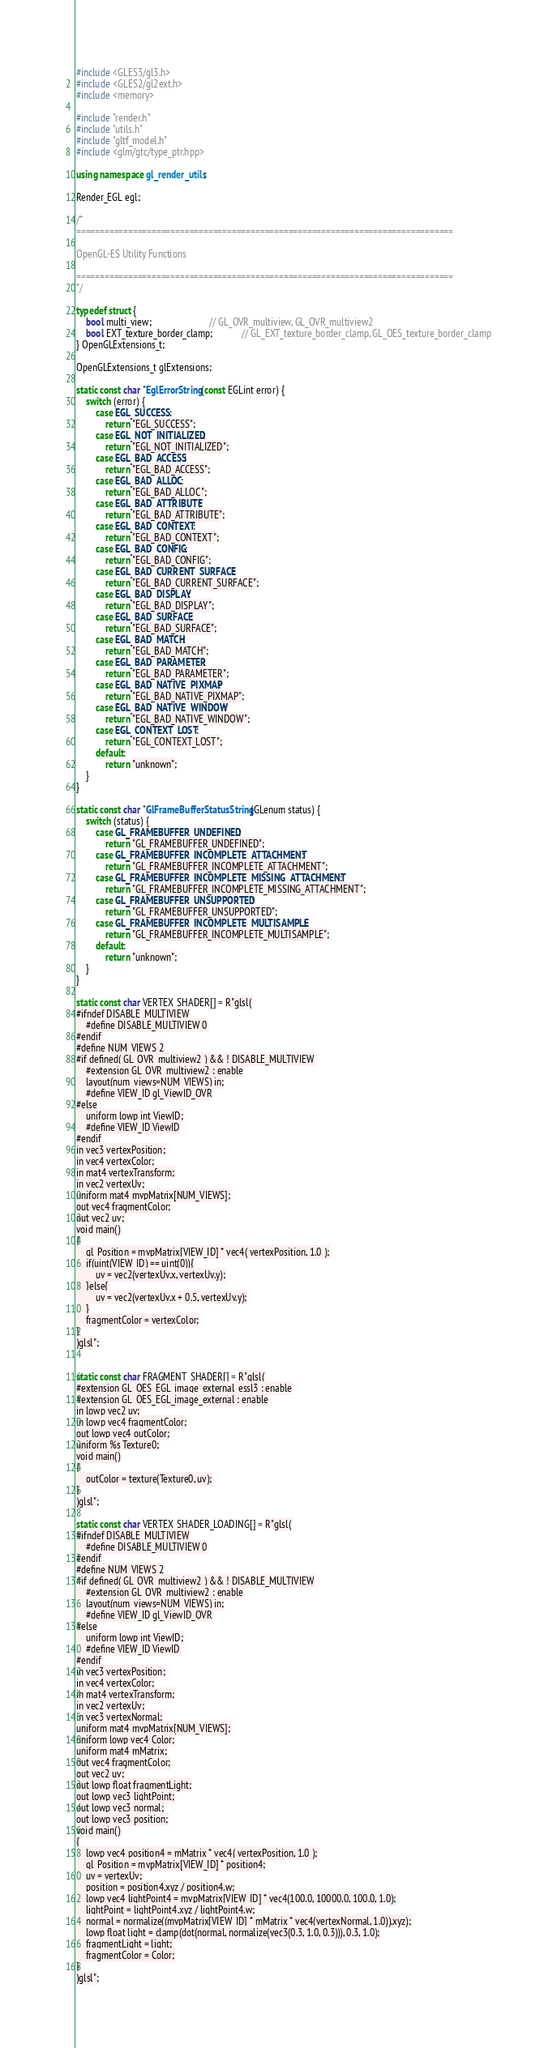<code> <loc_0><loc_0><loc_500><loc_500><_C++_>#include <GLES3/gl3.h>
#include <GLES2/gl2ext.h>
#include <memory>

#include "render.h"
#include "utils.h"
#include "gltf_model.h"
#include <glm/gtc/type_ptr.hpp>

using namespace gl_render_utils;

Render_EGL egl;

/*
================================================================================

OpenGL-ES Utility Functions

================================================================================
*/

typedef struct {
    bool multi_view;                        // GL_OVR_multiview, GL_OVR_multiview2
    bool EXT_texture_border_clamp;            // GL_EXT_texture_border_clamp, GL_OES_texture_border_clamp
} OpenGLExtensions_t;

OpenGLExtensions_t glExtensions;

static const char *EglErrorString(const EGLint error) {
    switch (error) {
        case EGL_SUCCESS:
            return "EGL_SUCCESS";
        case EGL_NOT_INITIALIZED:
            return "EGL_NOT_INITIALIZED";
        case EGL_BAD_ACCESS:
            return "EGL_BAD_ACCESS";
        case EGL_BAD_ALLOC:
            return "EGL_BAD_ALLOC";
        case EGL_BAD_ATTRIBUTE:
            return "EGL_BAD_ATTRIBUTE";
        case EGL_BAD_CONTEXT:
            return "EGL_BAD_CONTEXT";
        case EGL_BAD_CONFIG:
            return "EGL_BAD_CONFIG";
        case EGL_BAD_CURRENT_SURFACE:
            return "EGL_BAD_CURRENT_SURFACE";
        case EGL_BAD_DISPLAY:
            return "EGL_BAD_DISPLAY";
        case EGL_BAD_SURFACE:
            return "EGL_BAD_SURFACE";
        case EGL_BAD_MATCH:
            return "EGL_BAD_MATCH";
        case EGL_BAD_PARAMETER:
            return "EGL_BAD_PARAMETER";
        case EGL_BAD_NATIVE_PIXMAP:
            return "EGL_BAD_NATIVE_PIXMAP";
        case EGL_BAD_NATIVE_WINDOW:
            return "EGL_BAD_NATIVE_WINDOW";
        case EGL_CONTEXT_LOST:
            return "EGL_CONTEXT_LOST";
        default:
            return "unknown";
    }
}

static const char *GlFrameBufferStatusString(GLenum status) {
    switch (status) {
        case GL_FRAMEBUFFER_UNDEFINED:
            return "GL_FRAMEBUFFER_UNDEFINED";
        case GL_FRAMEBUFFER_INCOMPLETE_ATTACHMENT:
            return "GL_FRAMEBUFFER_INCOMPLETE_ATTACHMENT";
        case GL_FRAMEBUFFER_INCOMPLETE_MISSING_ATTACHMENT:
            return "GL_FRAMEBUFFER_INCOMPLETE_MISSING_ATTACHMENT";
        case GL_FRAMEBUFFER_UNSUPPORTED:
            return "GL_FRAMEBUFFER_UNSUPPORTED";
        case GL_FRAMEBUFFER_INCOMPLETE_MULTISAMPLE:
            return "GL_FRAMEBUFFER_INCOMPLETE_MULTISAMPLE";
        default:
            return "unknown";
    }
}

static const char VERTEX_SHADER[] = R"glsl(
#ifndef DISABLE_MULTIVIEW
    #define DISABLE_MULTIVIEW 0
#endif
#define NUM_VIEWS 2
#if defined( GL_OVR_multiview2 ) && ! DISABLE_MULTIVIEW
    #extension GL_OVR_multiview2 : enable
    layout(num_views=NUM_VIEWS) in;
    #define VIEW_ID gl_ViewID_OVR
#else
    uniform lowp int ViewID;
    #define VIEW_ID ViewID
#endif
in vec3 vertexPosition;
in vec4 vertexColor;
in mat4 vertexTransform;
in vec2 vertexUv;
uniform mat4 mvpMatrix[NUM_VIEWS];
out vec4 fragmentColor;
out vec2 uv;
void main()
{
    gl_Position = mvpMatrix[VIEW_ID] * vec4( vertexPosition, 1.0 );
    if(uint(VIEW_ID) == uint(0)){
        uv = vec2(vertexUv.x, vertexUv.y);
    }else{
        uv = vec2(vertexUv.x + 0.5, vertexUv.y);
    }
    fragmentColor = vertexColor;
}
)glsl";


static const char FRAGMENT_SHADER[] = R"glsl(
#extension GL_OES_EGL_image_external_essl3 : enable
#extension GL_OES_EGL_image_external : enable
in lowp vec2 uv;
in lowp vec4 fragmentColor;
out lowp vec4 outColor;
uniform %s Texture0;
void main()
{
    outColor = texture(Texture0, uv);
}
)glsl";

static const char VERTEX_SHADER_LOADING[] = R"glsl(
#ifndef DISABLE_MULTIVIEW
    #define DISABLE_MULTIVIEW 0
#endif
#define NUM_VIEWS 2
#if defined( GL_OVR_multiview2 ) && ! DISABLE_MULTIVIEW
    #extension GL_OVR_multiview2 : enable
    layout(num_views=NUM_VIEWS) in;
    #define VIEW_ID gl_ViewID_OVR
#else
    uniform lowp int ViewID;
    #define VIEW_ID ViewID
#endif
in vec3 vertexPosition;
in vec4 vertexColor;
in mat4 vertexTransform;
in vec2 vertexUv;
in vec3 vertexNormal;
uniform mat4 mvpMatrix[NUM_VIEWS];
uniform lowp vec4 Color;
uniform mat4 mMatrix;
out vec4 fragmentColor;
out vec2 uv;
out lowp float fragmentLight;
out lowp vec3 lightPoint;
out lowp vec3 normal;
out lowp vec3 position;
void main()
{
    lowp vec4 position4 = mMatrix * vec4( vertexPosition, 1.0 );
    gl_Position = mvpMatrix[VIEW_ID] * position4;
    uv = vertexUv;
    position = position4.xyz / position4.w;
    lowp vec4 lightPoint4 = mvpMatrix[VIEW_ID] * vec4(100.0, 10000.0, 100.0, 1.0);
    lightPoint = lightPoint4.xyz / lightPoint4.w;
    normal = normalize((mvpMatrix[VIEW_ID] * mMatrix * vec4(vertexNormal, 1.0)).xyz);
    lowp float light = clamp(dot(normal, normalize(vec3(0.3, 1.0, 0.3))), 0.3, 1.0);
    fragmentLight = light;
    fragmentColor = Color;
}
)glsl";
</code> 